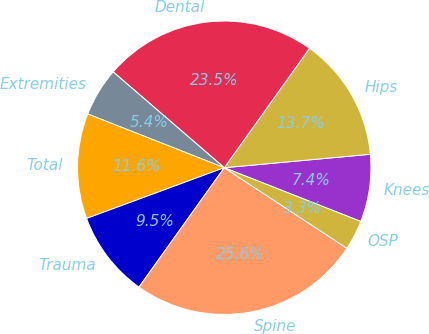Convert chart. <chart><loc_0><loc_0><loc_500><loc_500><pie_chart><fcel>Knees<fcel>Hips<fcel>Dental<fcel>Extremities<fcel>Total<fcel>Trauma<fcel>Spine<fcel>OSP<nl><fcel>7.43%<fcel>13.67%<fcel>23.54%<fcel>5.36%<fcel>11.59%<fcel>9.51%<fcel>25.62%<fcel>3.28%<nl></chart> 